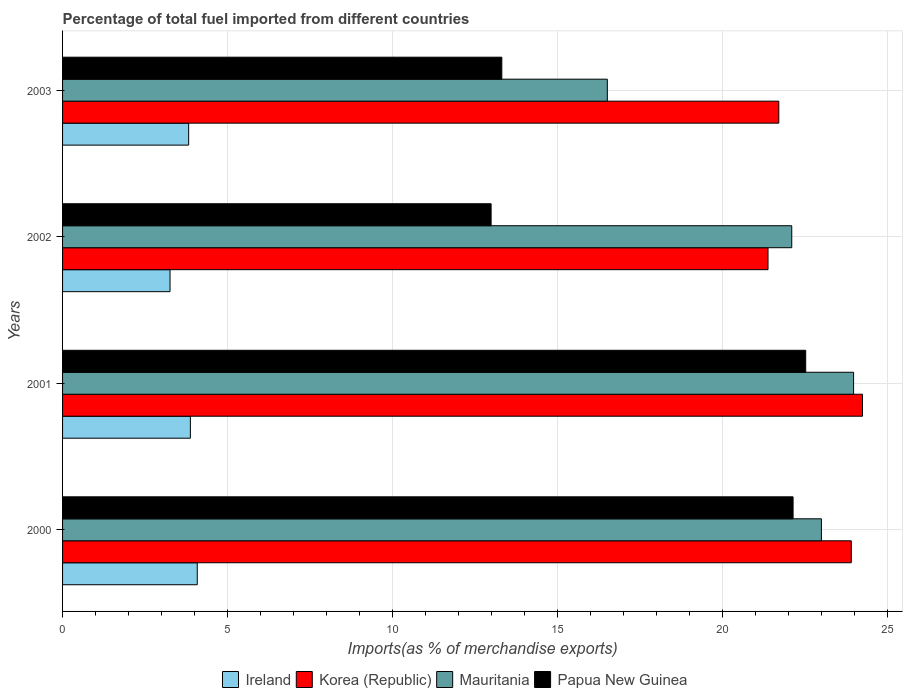How many different coloured bars are there?
Ensure brevity in your answer.  4. Are the number of bars on each tick of the Y-axis equal?
Ensure brevity in your answer.  Yes. How many bars are there on the 3rd tick from the top?
Offer a terse response. 4. What is the label of the 1st group of bars from the top?
Keep it short and to the point. 2003. In how many cases, is the number of bars for a given year not equal to the number of legend labels?
Ensure brevity in your answer.  0. What is the percentage of imports to different countries in Papua New Guinea in 2003?
Keep it short and to the point. 13.31. Across all years, what is the maximum percentage of imports to different countries in Korea (Republic)?
Offer a very short reply. 24.23. Across all years, what is the minimum percentage of imports to different countries in Papua New Guinea?
Give a very brief answer. 12.98. In which year was the percentage of imports to different countries in Ireland maximum?
Ensure brevity in your answer.  2000. In which year was the percentage of imports to different countries in Mauritania minimum?
Offer a terse response. 2003. What is the total percentage of imports to different countries in Papua New Guinea in the graph?
Offer a terse response. 70.92. What is the difference between the percentage of imports to different countries in Ireland in 2001 and that in 2003?
Your response must be concise. 0.05. What is the difference between the percentage of imports to different countries in Korea (Republic) in 2003 and the percentage of imports to different countries in Ireland in 2002?
Your answer should be compact. 18.44. What is the average percentage of imports to different countries in Korea (Republic) per year?
Offer a very short reply. 22.8. In the year 2002, what is the difference between the percentage of imports to different countries in Papua New Guinea and percentage of imports to different countries in Ireland?
Ensure brevity in your answer.  9.73. In how many years, is the percentage of imports to different countries in Ireland greater than 9 %?
Provide a short and direct response. 0. What is the ratio of the percentage of imports to different countries in Ireland in 2000 to that in 2002?
Keep it short and to the point. 1.25. What is the difference between the highest and the second highest percentage of imports to different countries in Ireland?
Your answer should be very brief. 0.21. What is the difference between the highest and the lowest percentage of imports to different countries in Papua New Guinea?
Make the answer very short. 9.53. In how many years, is the percentage of imports to different countries in Ireland greater than the average percentage of imports to different countries in Ireland taken over all years?
Provide a succinct answer. 3. Is the sum of the percentage of imports to different countries in Ireland in 2000 and 2003 greater than the maximum percentage of imports to different countries in Papua New Guinea across all years?
Keep it short and to the point. No. What does the 1st bar from the bottom in 2000 represents?
Provide a succinct answer. Ireland. Is it the case that in every year, the sum of the percentage of imports to different countries in Mauritania and percentage of imports to different countries in Papua New Guinea is greater than the percentage of imports to different countries in Ireland?
Offer a very short reply. Yes. Are all the bars in the graph horizontal?
Your answer should be very brief. Yes. How many years are there in the graph?
Your answer should be very brief. 4. What is the difference between two consecutive major ticks on the X-axis?
Ensure brevity in your answer.  5. How many legend labels are there?
Provide a succinct answer. 4. What is the title of the graph?
Ensure brevity in your answer.  Percentage of total fuel imported from different countries. What is the label or title of the X-axis?
Ensure brevity in your answer.  Imports(as % of merchandise exports). What is the Imports(as % of merchandise exports) of Ireland in 2000?
Your answer should be compact. 4.08. What is the Imports(as % of merchandise exports) of Korea (Republic) in 2000?
Give a very brief answer. 23.89. What is the Imports(as % of merchandise exports) of Mauritania in 2000?
Your answer should be very brief. 22.99. What is the Imports(as % of merchandise exports) in Papua New Guinea in 2000?
Make the answer very short. 22.13. What is the Imports(as % of merchandise exports) of Ireland in 2001?
Offer a very short reply. 3.87. What is the Imports(as % of merchandise exports) of Korea (Republic) in 2001?
Your response must be concise. 24.23. What is the Imports(as % of merchandise exports) of Mauritania in 2001?
Provide a succinct answer. 23.96. What is the Imports(as % of merchandise exports) of Papua New Guinea in 2001?
Provide a succinct answer. 22.51. What is the Imports(as % of merchandise exports) in Ireland in 2002?
Your response must be concise. 3.26. What is the Imports(as % of merchandise exports) of Korea (Republic) in 2002?
Give a very brief answer. 21.37. What is the Imports(as % of merchandise exports) of Mauritania in 2002?
Keep it short and to the point. 22.09. What is the Imports(as % of merchandise exports) in Papua New Guinea in 2002?
Provide a succinct answer. 12.98. What is the Imports(as % of merchandise exports) of Ireland in 2003?
Ensure brevity in your answer.  3.82. What is the Imports(as % of merchandise exports) in Korea (Republic) in 2003?
Provide a succinct answer. 21.69. What is the Imports(as % of merchandise exports) in Mauritania in 2003?
Provide a short and direct response. 16.5. What is the Imports(as % of merchandise exports) of Papua New Guinea in 2003?
Provide a short and direct response. 13.31. Across all years, what is the maximum Imports(as % of merchandise exports) of Ireland?
Make the answer very short. 4.08. Across all years, what is the maximum Imports(as % of merchandise exports) of Korea (Republic)?
Ensure brevity in your answer.  24.23. Across all years, what is the maximum Imports(as % of merchandise exports) in Mauritania?
Provide a succinct answer. 23.96. Across all years, what is the maximum Imports(as % of merchandise exports) of Papua New Guinea?
Offer a very short reply. 22.51. Across all years, what is the minimum Imports(as % of merchandise exports) in Ireland?
Keep it short and to the point. 3.26. Across all years, what is the minimum Imports(as % of merchandise exports) in Korea (Republic)?
Your response must be concise. 21.37. Across all years, what is the minimum Imports(as % of merchandise exports) in Mauritania?
Your answer should be compact. 16.5. Across all years, what is the minimum Imports(as % of merchandise exports) of Papua New Guinea?
Give a very brief answer. 12.98. What is the total Imports(as % of merchandise exports) of Ireland in the graph?
Provide a succinct answer. 15.03. What is the total Imports(as % of merchandise exports) in Korea (Republic) in the graph?
Keep it short and to the point. 91.18. What is the total Imports(as % of merchandise exports) of Mauritania in the graph?
Ensure brevity in your answer.  85.54. What is the total Imports(as % of merchandise exports) of Papua New Guinea in the graph?
Offer a very short reply. 70.92. What is the difference between the Imports(as % of merchandise exports) in Ireland in 2000 and that in 2001?
Offer a very short reply. 0.21. What is the difference between the Imports(as % of merchandise exports) in Korea (Republic) in 2000 and that in 2001?
Your response must be concise. -0.34. What is the difference between the Imports(as % of merchandise exports) in Mauritania in 2000 and that in 2001?
Keep it short and to the point. -0.97. What is the difference between the Imports(as % of merchandise exports) in Papua New Guinea in 2000 and that in 2001?
Provide a succinct answer. -0.38. What is the difference between the Imports(as % of merchandise exports) of Ireland in 2000 and that in 2002?
Ensure brevity in your answer.  0.82. What is the difference between the Imports(as % of merchandise exports) in Korea (Republic) in 2000 and that in 2002?
Offer a terse response. 2.52. What is the difference between the Imports(as % of merchandise exports) of Mauritania in 2000 and that in 2002?
Make the answer very short. 0.9. What is the difference between the Imports(as % of merchandise exports) of Papua New Guinea in 2000 and that in 2002?
Your response must be concise. 9.15. What is the difference between the Imports(as % of merchandise exports) in Ireland in 2000 and that in 2003?
Your answer should be very brief. 0.26. What is the difference between the Imports(as % of merchandise exports) of Korea (Republic) in 2000 and that in 2003?
Your response must be concise. 2.2. What is the difference between the Imports(as % of merchandise exports) of Mauritania in 2000 and that in 2003?
Your answer should be very brief. 6.48. What is the difference between the Imports(as % of merchandise exports) of Papua New Guinea in 2000 and that in 2003?
Provide a short and direct response. 8.82. What is the difference between the Imports(as % of merchandise exports) of Ireland in 2001 and that in 2002?
Give a very brief answer. 0.62. What is the difference between the Imports(as % of merchandise exports) in Korea (Republic) in 2001 and that in 2002?
Offer a terse response. 2.86. What is the difference between the Imports(as % of merchandise exports) in Mauritania in 2001 and that in 2002?
Your response must be concise. 1.87. What is the difference between the Imports(as % of merchandise exports) of Papua New Guinea in 2001 and that in 2002?
Make the answer very short. 9.53. What is the difference between the Imports(as % of merchandise exports) in Ireland in 2001 and that in 2003?
Offer a terse response. 0.05. What is the difference between the Imports(as % of merchandise exports) of Korea (Republic) in 2001 and that in 2003?
Your answer should be compact. 2.54. What is the difference between the Imports(as % of merchandise exports) of Mauritania in 2001 and that in 2003?
Provide a succinct answer. 7.46. What is the difference between the Imports(as % of merchandise exports) in Papua New Guinea in 2001 and that in 2003?
Your answer should be compact. 9.2. What is the difference between the Imports(as % of merchandise exports) of Ireland in 2002 and that in 2003?
Make the answer very short. -0.56. What is the difference between the Imports(as % of merchandise exports) in Korea (Republic) in 2002 and that in 2003?
Offer a very short reply. -0.33. What is the difference between the Imports(as % of merchandise exports) of Mauritania in 2002 and that in 2003?
Ensure brevity in your answer.  5.59. What is the difference between the Imports(as % of merchandise exports) of Papua New Guinea in 2002 and that in 2003?
Keep it short and to the point. -0.32. What is the difference between the Imports(as % of merchandise exports) of Ireland in 2000 and the Imports(as % of merchandise exports) of Korea (Republic) in 2001?
Offer a terse response. -20.15. What is the difference between the Imports(as % of merchandise exports) of Ireland in 2000 and the Imports(as % of merchandise exports) of Mauritania in 2001?
Your answer should be compact. -19.88. What is the difference between the Imports(as % of merchandise exports) in Ireland in 2000 and the Imports(as % of merchandise exports) in Papua New Guinea in 2001?
Keep it short and to the point. -18.43. What is the difference between the Imports(as % of merchandise exports) in Korea (Republic) in 2000 and the Imports(as % of merchandise exports) in Mauritania in 2001?
Give a very brief answer. -0.07. What is the difference between the Imports(as % of merchandise exports) of Korea (Republic) in 2000 and the Imports(as % of merchandise exports) of Papua New Guinea in 2001?
Give a very brief answer. 1.38. What is the difference between the Imports(as % of merchandise exports) of Mauritania in 2000 and the Imports(as % of merchandise exports) of Papua New Guinea in 2001?
Keep it short and to the point. 0.48. What is the difference between the Imports(as % of merchandise exports) of Ireland in 2000 and the Imports(as % of merchandise exports) of Korea (Republic) in 2002?
Your answer should be very brief. -17.29. What is the difference between the Imports(as % of merchandise exports) of Ireland in 2000 and the Imports(as % of merchandise exports) of Mauritania in 2002?
Make the answer very short. -18.01. What is the difference between the Imports(as % of merchandise exports) in Ireland in 2000 and the Imports(as % of merchandise exports) in Papua New Guinea in 2002?
Your answer should be very brief. -8.9. What is the difference between the Imports(as % of merchandise exports) in Korea (Republic) in 2000 and the Imports(as % of merchandise exports) in Mauritania in 2002?
Keep it short and to the point. 1.8. What is the difference between the Imports(as % of merchandise exports) of Korea (Republic) in 2000 and the Imports(as % of merchandise exports) of Papua New Guinea in 2002?
Offer a very short reply. 10.91. What is the difference between the Imports(as % of merchandise exports) of Mauritania in 2000 and the Imports(as % of merchandise exports) of Papua New Guinea in 2002?
Provide a succinct answer. 10.01. What is the difference between the Imports(as % of merchandise exports) of Ireland in 2000 and the Imports(as % of merchandise exports) of Korea (Republic) in 2003?
Your answer should be compact. -17.62. What is the difference between the Imports(as % of merchandise exports) in Ireland in 2000 and the Imports(as % of merchandise exports) in Mauritania in 2003?
Offer a very short reply. -12.42. What is the difference between the Imports(as % of merchandise exports) of Ireland in 2000 and the Imports(as % of merchandise exports) of Papua New Guinea in 2003?
Give a very brief answer. -9.23. What is the difference between the Imports(as % of merchandise exports) in Korea (Republic) in 2000 and the Imports(as % of merchandise exports) in Mauritania in 2003?
Your answer should be compact. 7.39. What is the difference between the Imports(as % of merchandise exports) in Korea (Republic) in 2000 and the Imports(as % of merchandise exports) in Papua New Guinea in 2003?
Your response must be concise. 10.59. What is the difference between the Imports(as % of merchandise exports) in Mauritania in 2000 and the Imports(as % of merchandise exports) in Papua New Guinea in 2003?
Your response must be concise. 9.68. What is the difference between the Imports(as % of merchandise exports) in Ireland in 2001 and the Imports(as % of merchandise exports) in Korea (Republic) in 2002?
Keep it short and to the point. -17.5. What is the difference between the Imports(as % of merchandise exports) of Ireland in 2001 and the Imports(as % of merchandise exports) of Mauritania in 2002?
Your response must be concise. -18.22. What is the difference between the Imports(as % of merchandise exports) in Ireland in 2001 and the Imports(as % of merchandise exports) in Papua New Guinea in 2002?
Your answer should be compact. -9.11. What is the difference between the Imports(as % of merchandise exports) in Korea (Republic) in 2001 and the Imports(as % of merchandise exports) in Mauritania in 2002?
Provide a short and direct response. 2.14. What is the difference between the Imports(as % of merchandise exports) of Korea (Republic) in 2001 and the Imports(as % of merchandise exports) of Papua New Guinea in 2002?
Your answer should be compact. 11.25. What is the difference between the Imports(as % of merchandise exports) in Mauritania in 2001 and the Imports(as % of merchandise exports) in Papua New Guinea in 2002?
Make the answer very short. 10.98. What is the difference between the Imports(as % of merchandise exports) in Ireland in 2001 and the Imports(as % of merchandise exports) in Korea (Republic) in 2003?
Give a very brief answer. -17.82. What is the difference between the Imports(as % of merchandise exports) in Ireland in 2001 and the Imports(as % of merchandise exports) in Mauritania in 2003?
Your response must be concise. -12.63. What is the difference between the Imports(as % of merchandise exports) in Ireland in 2001 and the Imports(as % of merchandise exports) in Papua New Guinea in 2003?
Offer a terse response. -9.43. What is the difference between the Imports(as % of merchandise exports) in Korea (Republic) in 2001 and the Imports(as % of merchandise exports) in Mauritania in 2003?
Keep it short and to the point. 7.73. What is the difference between the Imports(as % of merchandise exports) in Korea (Republic) in 2001 and the Imports(as % of merchandise exports) in Papua New Guinea in 2003?
Offer a terse response. 10.93. What is the difference between the Imports(as % of merchandise exports) of Mauritania in 2001 and the Imports(as % of merchandise exports) of Papua New Guinea in 2003?
Ensure brevity in your answer.  10.66. What is the difference between the Imports(as % of merchandise exports) in Ireland in 2002 and the Imports(as % of merchandise exports) in Korea (Republic) in 2003?
Your answer should be compact. -18.44. What is the difference between the Imports(as % of merchandise exports) of Ireland in 2002 and the Imports(as % of merchandise exports) of Mauritania in 2003?
Your answer should be compact. -13.25. What is the difference between the Imports(as % of merchandise exports) in Ireland in 2002 and the Imports(as % of merchandise exports) in Papua New Guinea in 2003?
Provide a short and direct response. -10.05. What is the difference between the Imports(as % of merchandise exports) of Korea (Republic) in 2002 and the Imports(as % of merchandise exports) of Mauritania in 2003?
Your answer should be very brief. 4.87. What is the difference between the Imports(as % of merchandise exports) in Korea (Republic) in 2002 and the Imports(as % of merchandise exports) in Papua New Guinea in 2003?
Your answer should be very brief. 8.06. What is the difference between the Imports(as % of merchandise exports) of Mauritania in 2002 and the Imports(as % of merchandise exports) of Papua New Guinea in 2003?
Provide a succinct answer. 8.78. What is the average Imports(as % of merchandise exports) of Ireland per year?
Offer a very short reply. 3.76. What is the average Imports(as % of merchandise exports) in Korea (Republic) per year?
Your answer should be very brief. 22.8. What is the average Imports(as % of merchandise exports) in Mauritania per year?
Your response must be concise. 21.38. What is the average Imports(as % of merchandise exports) in Papua New Guinea per year?
Keep it short and to the point. 17.73. In the year 2000, what is the difference between the Imports(as % of merchandise exports) of Ireland and Imports(as % of merchandise exports) of Korea (Republic)?
Provide a short and direct response. -19.81. In the year 2000, what is the difference between the Imports(as % of merchandise exports) of Ireland and Imports(as % of merchandise exports) of Mauritania?
Ensure brevity in your answer.  -18.91. In the year 2000, what is the difference between the Imports(as % of merchandise exports) in Ireland and Imports(as % of merchandise exports) in Papua New Guinea?
Make the answer very short. -18.05. In the year 2000, what is the difference between the Imports(as % of merchandise exports) in Korea (Republic) and Imports(as % of merchandise exports) in Mauritania?
Offer a very short reply. 0.9. In the year 2000, what is the difference between the Imports(as % of merchandise exports) in Korea (Republic) and Imports(as % of merchandise exports) in Papua New Guinea?
Your answer should be compact. 1.76. In the year 2000, what is the difference between the Imports(as % of merchandise exports) in Mauritania and Imports(as % of merchandise exports) in Papua New Guinea?
Your response must be concise. 0.86. In the year 2001, what is the difference between the Imports(as % of merchandise exports) of Ireland and Imports(as % of merchandise exports) of Korea (Republic)?
Offer a terse response. -20.36. In the year 2001, what is the difference between the Imports(as % of merchandise exports) of Ireland and Imports(as % of merchandise exports) of Mauritania?
Offer a very short reply. -20.09. In the year 2001, what is the difference between the Imports(as % of merchandise exports) of Ireland and Imports(as % of merchandise exports) of Papua New Guinea?
Your answer should be compact. -18.64. In the year 2001, what is the difference between the Imports(as % of merchandise exports) of Korea (Republic) and Imports(as % of merchandise exports) of Mauritania?
Offer a terse response. 0.27. In the year 2001, what is the difference between the Imports(as % of merchandise exports) of Korea (Republic) and Imports(as % of merchandise exports) of Papua New Guinea?
Offer a terse response. 1.72. In the year 2001, what is the difference between the Imports(as % of merchandise exports) of Mauritania and Imports(as % of merchandise exports) of Papua New Guinea?
Offer a very short reply. 1.45. In the year 2002, what is the difference between the Imports(as % of merchandise exports) of Ireland and Imports(as % of merchandise exports) of Korea (Republic)?
Your answer should be very brief. -18.11. In the year 2002, what is the difference between the Imports(as % of merchandise exports) in Ireland and Imports(as % of merchandise exports) in Mauritania?
Make the answer very short. -18.83. In the year 2002, what is the difference between the Imports(as % of merchandise exports) in Ireland and Imports(as % of merchandise exports) in Papua New Guinea?
Offer a very short reply. -9.73. In the year 2002, what is the difference between the Imports(as % of merchandise exports) in Korea (Republic) and Imports(as % of merchandise exports) in Mauritania?
Keep it short and to the point. -0.72. In the year 2002, what is the difference between the Imports(as % of merchandise exports) in Korea (Republic) and Imports(as % of merchandise exports) in Papua New Guinea?
Your response must be concise. 8.39. In the year 2002, what is the difference between the Imports(as % of merchandise exports) of Mauritania and Imports(as % of merchandise exports) of Papua New Guinea?
Make the answer very short. 9.11. In the year 2003, what is the difference between the Imports(as % of merchandise exports) in Ireland and Imports(as % of merchandise exports) in Korea (Republic)?
Keep it short and to the point. -17.88. In the year 2003, what is the difference between the Imports(as % of merchandise exports) of Ireland and Imports(as % of merchandise exports) of Mauritania?
Provide a short and direct response. -12.68. In the year 2003, what is the difference between the Imports(as % of merchandise exports) of Ireland and Imports(as % of merchandise exports) of Papua New Guinea?
Keep it short and to the point. -9.49. In the year 2003, what is the difference between the Imports(as % of merchandise exports) of Korea (Republic) and Imports(as % of merchandise exports) of Mauritania?
Provide a short and direct response. 5.19. In the year 2003, what is the difference between the Imports(as % of merchandise exports) of Korea (Republic) and Imports(as % of merchandise exports) of Papua New Guinea?
Make the answer very short. 8.39. In the year 2003, what is the difference between the Imports(as % of merchandise exports) in Mauritania and Imports(as % of merchandise exports) in Papua New Guinea?
Ensure brevity in your answer.  3.2. What is the ratio of the Imports(as % of merchandise exports) in Ireland in 2000 to that in 2001?
Your response must be concise. 1.05. What is the ratio of the Imports(as % of merchandise exports) in Korea (Republic) in 2000 to that in 2001?
Your answer should be compact. 0.99. What is the ratio of the Imports(as % of merchandise exports) in Mauritania in 2000 to that in 2001?
Keep it short and to the point. 0.96. What is the ratio of the Imports(as % of merchandise exports) of Ireland in 2000 to that in 2002?
Ensure brevity in your answer.  1.25. What is the ratio of the Imports(as % of merchandise exports) in Korea (Republic) in 2000 to that in 2002?
Your answer should be compact. 1.12. What is the ratio of the Imports(as % of merchandise exports) in Mauritania in 2000 to that in 2002?
Your answer should be compact. 1.04. What is the ratio of the Imports(as % of merchandise exports) in Papua New Guinea in 2000 to that in 2002?
Make the answer very short. 1.7. What is the ratio of the Imports(as % of merchandise exports) of Ireland in 2000 to that in 2003?
Your response must be concise. 1.07. What is the ratio of the Imports(as % of merchandise exports) of Korea (Republic) in 2000 to that in 2003?
Offer a terse response. 1.1. What is the ratio of the Imports(as % of merchandise exports) in Mauritania in 2000 to that in 2003?
Make the answer very short. 1.39. What is the ratio of the Imports(as % of merchandise exports) of Papua New Guinea in 2000 to that in 2003?
Provide a short and direct response. 1.66. What is the ratio of the Imports(as % of merchandise exports) of Ireland in 2001 to that in 2002?
Your response must be concise. 1.19. What is the ratio of the Imports(as % of merchandise exports) of Korea (Republic) in 2001 to that in 2002?
Provide a short and direct response. 1.13. What is the ratio of the Imports(as % of merchandise exports) of Mauritania in 2001 to that in 2002?
Offer a very short reply. 1.08. What is the ratio of the Imports(as % of merchandise exports) in Papua New Guinea in 2001 to that in 2002?
Offer a very short reply. 1.73. What is the ratio of the Imports(as % of merchandise exports) in Ireland in 2001 to that in 2003?
Your response must be concise. 1.01. What is the ratio of the Imports(as % of merchandise exports) in Korea (Republic) in 2001 to that in 2003?
Provide a short and direct response. 1.12. What is the ratio of the Imports(as % of merchandise exports) of Mauritania in 2001 to that in 2003?
Ensure brevity in your answer.  1.45. What is the ratio of the Imports(as % of merchandise exports) in Papua New Guinea in 2001 to that in 2003?
Provide a succinct answer. 1.69. What is the ratio of the Imports(as % of merchandise exports) of Ireland in 2002 to that in 2003?
Your answer should be compact. 0.85. What is the ratio of the Imports(as % of merchandise exports) of Korea (Republic) in 2002 to that in 2003?
Provide a succinct answer. 0.98. What is the ratio of the Imports(as % of merchandise exports) in Mauritania in 2002 to that in 2003?
Give a very brief answer. 1.34. What is the ratio of the Imports(as % of merchandise exports) of Papua New Guinea in 2002 to that in 2003?
Give a very brief answer. 0.98. What is the difference between the highest and the second highest Imports(as % of merchandise exports) in Ireland?
Keep it short and to the point. 0.21. What is the difference between the highest and the second highest Imports(as % of merchandise exports) in Korea (Republic)?
Provide a short and direct response. 0.34. What is the difference between the highest and the second highest Imports(as % of merchandise exports) of Mauritania?
Offer a terse response. 0.97. What is the difference between the highest and the second highest Imports(as % of merchandise exports) in Papua New Guinea?
Keep it short and to the point. 0.38. What is the difference between the highest and the lowest Imports(as % of merchandise exports) of Ireland?
Your answer should be very brief. 0.82. What is the difference between the highest and the lowest Imports(as % of merchandise exports) of Korea (Republic)?
Your answer should be very brief. 2.86. What is the difference between the highest and the lowest Imports(as % of merchandise exports) of Mauritania?
Your response must be concise. 7.46. What is the difference between the highest and the lowest Imports(as % of merchandise exports) of Papua New Guinea?
Ensure brevity in your answer.  9.53. 